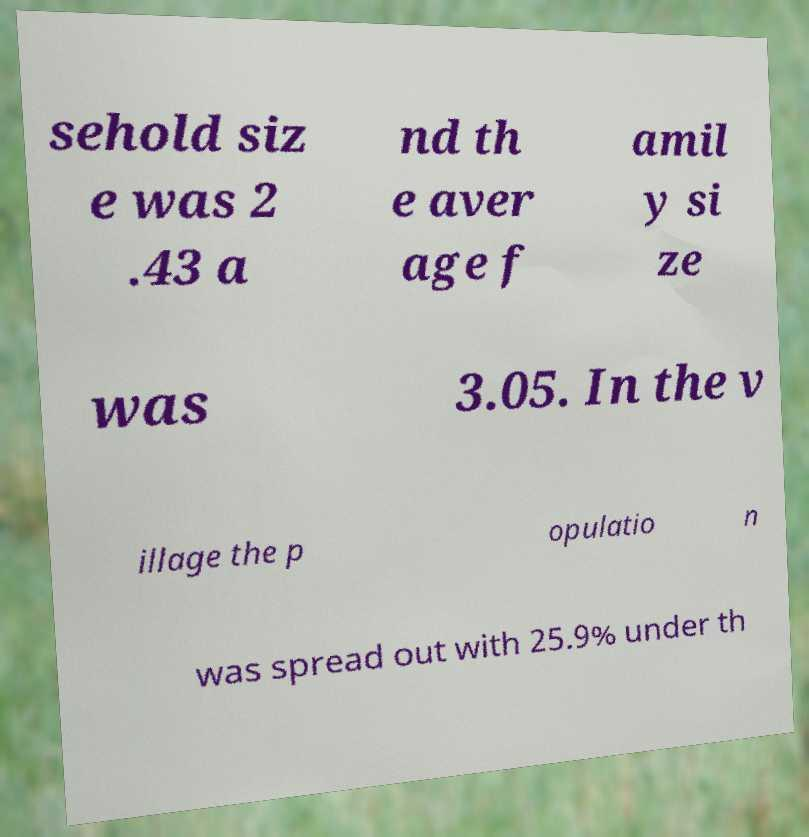Please identify and transcribe the text found in this image. sehold siz e was 2 .43 a nd th e aver age f amil y si ze was 3.05. In the v illage the p opulatio n was spread out with 25.9% under th 